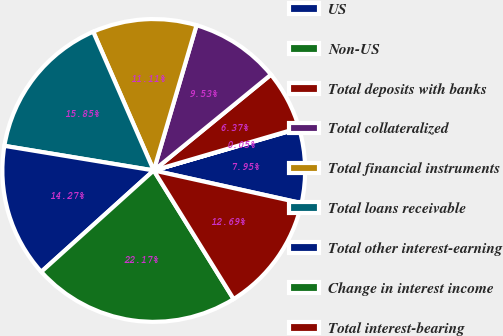<chart> <loc_0><loc_0><loc_500><loc_500><pie_chart><fcel>US<fcel>Non-US<fcel>Total deposits with banks<fcel>Total collateralized<fcel>Total financial instruments<fcel>Total loans receivable<fcel>Total other interest-earning<fcel>Change in interest income<fcel>Total interest-bearing<nl><fcel>7.95%<fcel>0.05%<fcel>6.37%<fcel>9.53%<fcel>11.11%<fcel>15.85%<fcel>14.27%<fcel>22.17%<fcel>12.69%<nl></chart> 